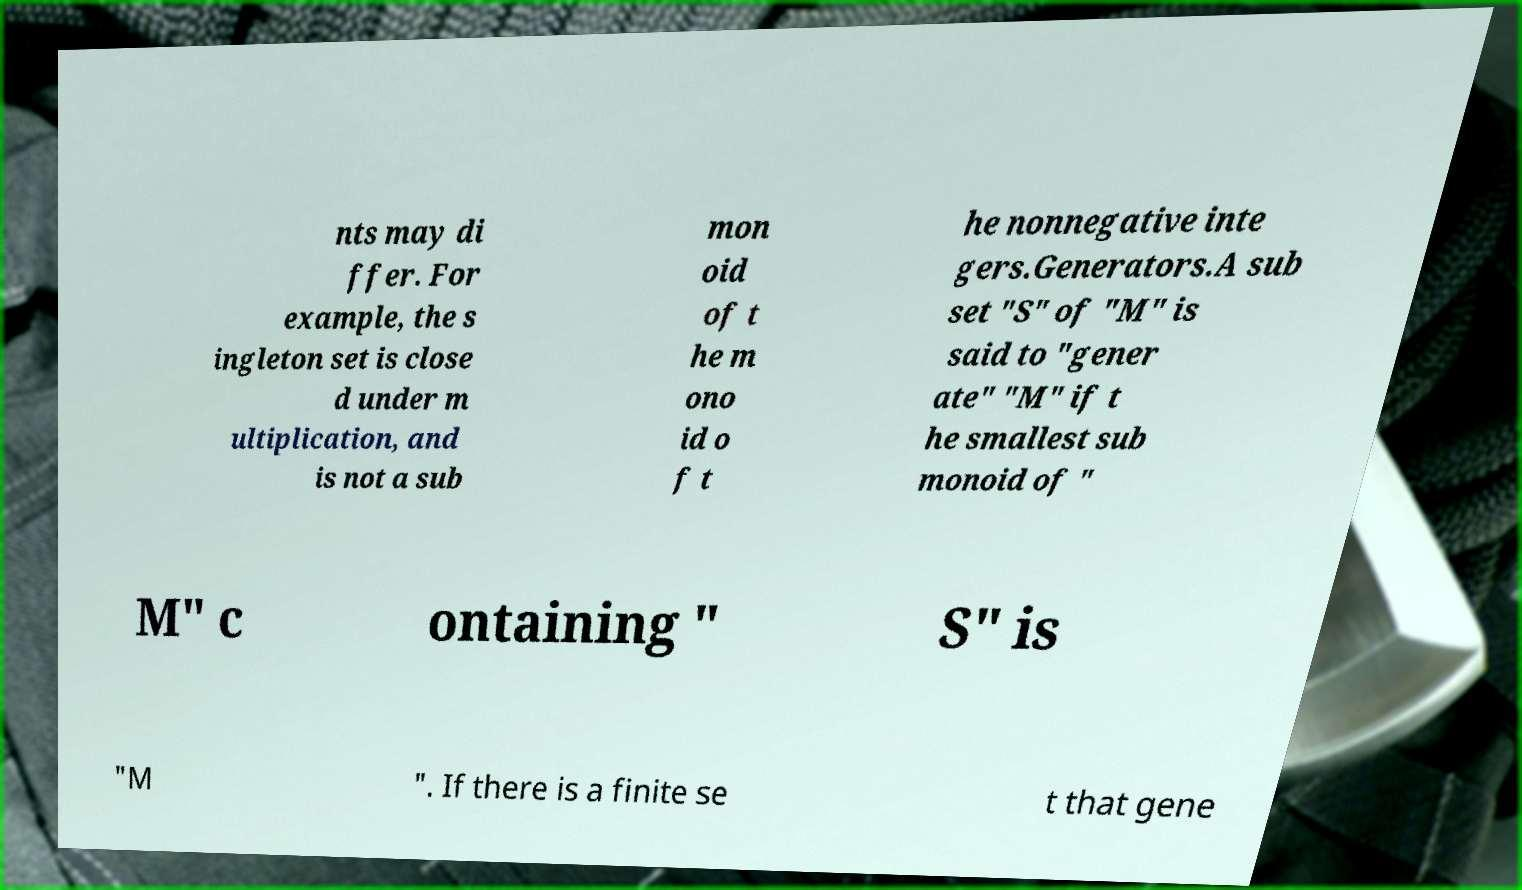Can you read and provide the text displayed in the image?This photo seems to have some interesting text. Can you extract and type it out for me? nts may di ffer. For example, the s ingleton set is close d under m ultiplication, and is not a sub mon oid of t he m ono id o f t he nonnegative inte gers.Generators.A sub set "S" of "M" is said to "gener ate" "M" if t he smallest sub monoid of " M" c ontaining " S" is "M ". If there is a finite se t that gene 